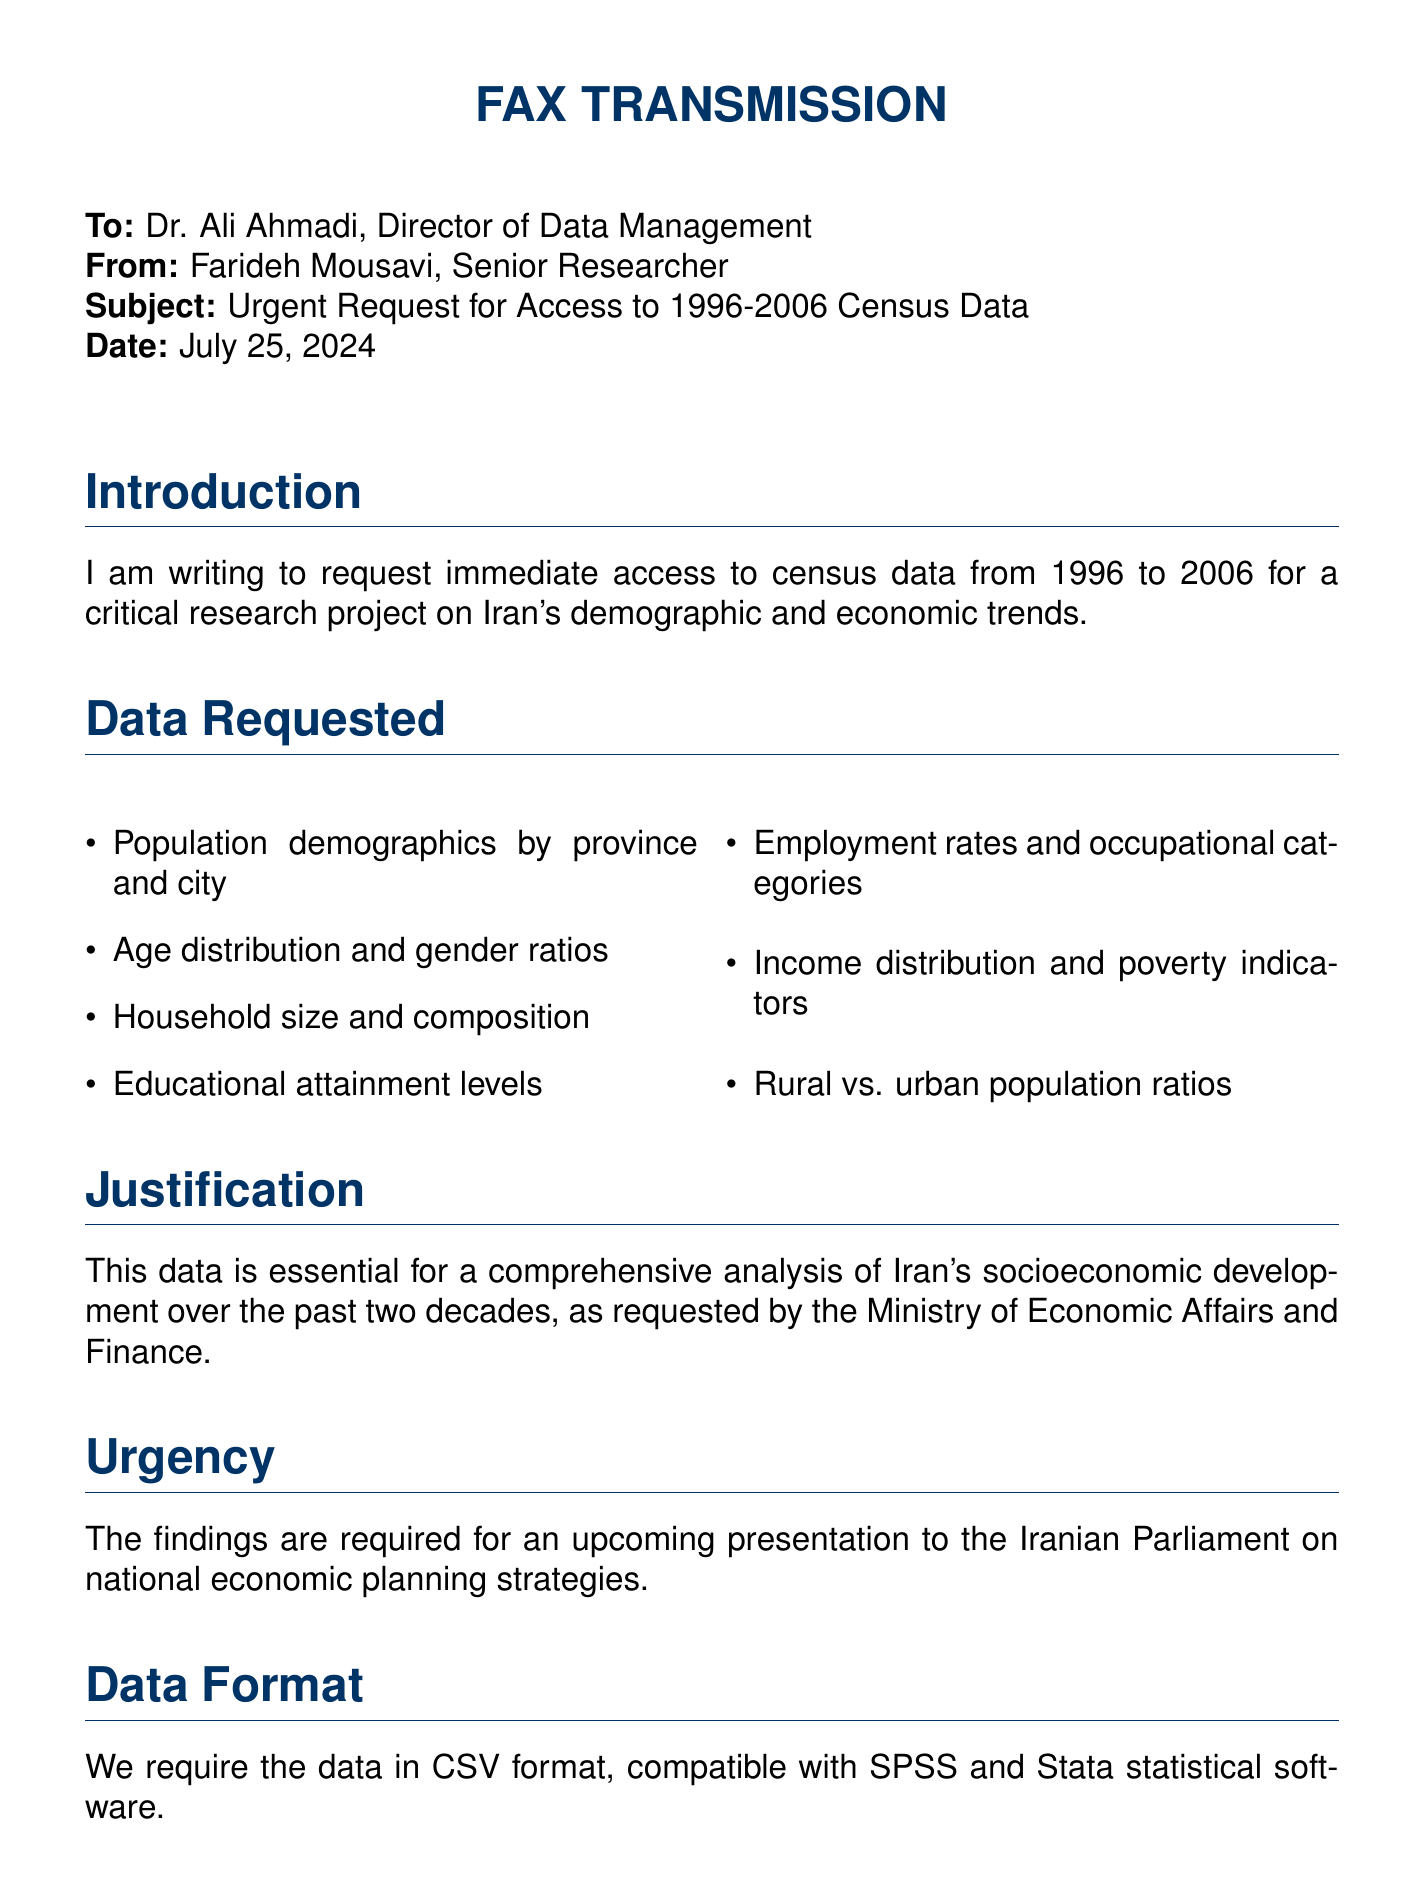What is the subject of the fax? The subject line clearly states the purpose of the fax, which is to request urgent access to census data.
Answer: Urgent Request for Access to 1996-2006 Census Data Who is the sender of the fax? The fax indicates who is sending it by stating the sender's name and title at the end.
Answer: Farideh Mousavi What years does the requested census data cover? The document specifies the range of years for which data is requested in the introduction section.
Answer: 1996-2006 What is the required data format? The document specifies the format in which the data is needed to ensure compatibility with software.
Answer: CSV format What is one of the key demographics requested? The list of demographics requested includes various aspects, one of which is mentioned.
Answer: Age distribution What is the urgency of this request related to? The urgency is emphasized in the document, linked to a specific presentation timeframe.
Answer: Presentation to the Iranian Parliament What will the data be used for? The justification section outlines the purpose of the data request surrounding a specific analysis.
Answer: Comprehensive analysis of Iran's socioeconomic development What is the position of the recipient? The recipient's role is stated in the "To" section of the fax, indicating their responsibility.
Answer: Director of Data Management What assurance is provided regarding data confidentiality? The document contains a statement assuring compliance with confidentiality protocols and intended use.
Answer: Strict compliance with confidentiality protocols 